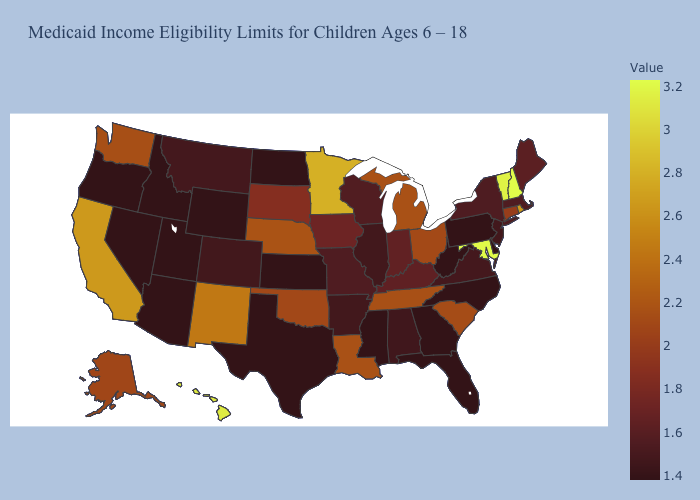Among the states that border Nebraska , does Missouri have the lowest value?
Answer briefly. No. Which states hav the highest value in the Northeast?
Quick response, please. New Hampshire. Among the states that border Nebraska , does Colorado have the lowest value?
Keep it brief. No. Which states have the lowest value in the South?
Short answer required. Delaware, Florida, Georgia, Mississippi, North Carolina, Texas, West Virginia. Does the map have missing data?
Write a very short answer. No. 